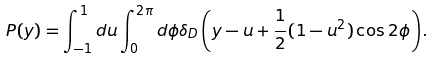Convert formula to latex. <formula><loc_0><loc_0><loc_500><loc_500>P ( y ) = \int _ { - 1 } ^ { 1 } d u \int _ { 0 } ^ { 2 \pi } d \phi \delta _ { D } \left ( y - u + \frac { 1 } { 2 } ( 1 - u ^ { 2 } ) \cos 2 \phi \right ) .</formula> 